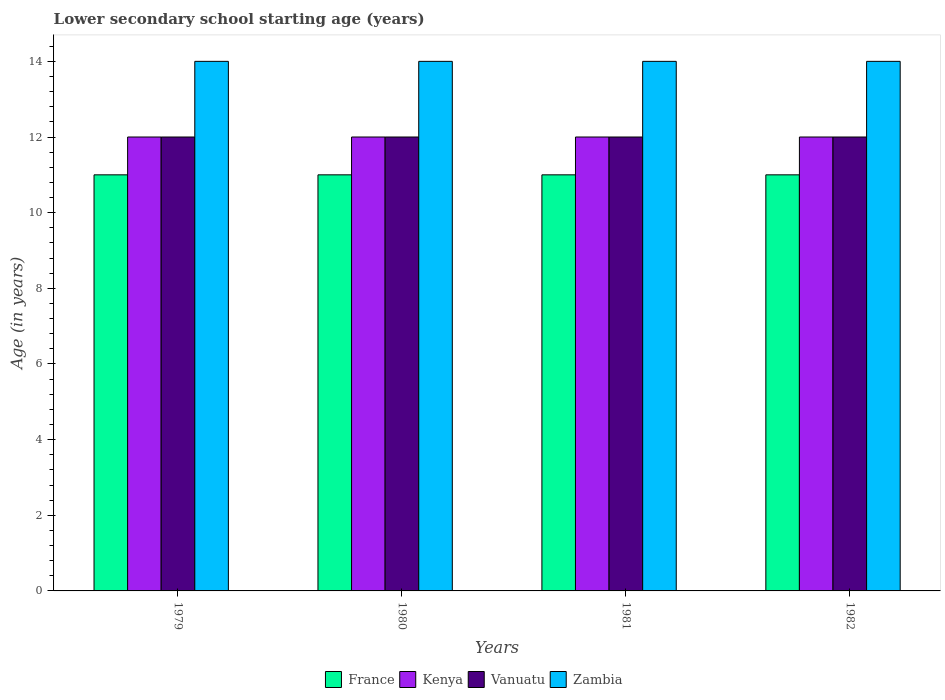How many different coloured bars are there?
Your answer should be compact. 4. How many groups of bars are there?
Provide a short and direct response. 4. Are the number of bars per tick equal to the number of legend labels?
Offer a very short reply. Yes. How many bars are there on the 1st tick from the right?
Provide a succinct answer. 4. What is the label of the 3rd group of bars from the left?
Provide a succinct answer. 1981. What is the lower secondary school starting age of children in Kenya in 1980?
Keep it short and to the point. 12. Across all years, what is the maximum lower secondary school starting age of children in Zambia?
Offer a terse response. 14. Across all years, what is the minimum lower secondary school starting age of children in France?
Make the answer very short. 11. In which year was the lower secondary school starting age of children in Zambia maximum?
Provide a succinct answer. 1979. In which year was the lower secondary school starting age of children in Zambia minimum?
Provide a succinct answer. 1979. What is the total lower secondary school starting age of children in France in the graph?
Ensure brevity in your answer.  44. What is the difference between the lower secondary school starting age of children in Zambia in 1979 and that in 1982?
Keep it short and to the point. 0. What is the difference between the lower secondary school starting age of children in Kenya in 1981 and the lower secondary school starting age of children in France in 1979?
Ensure brevity in your answer.  1. What is the average lower secondary school starting age of children in France per year?
Offer a terse response. 11. In the year 1982, what is the difference between the lower secondary school starting age of children in Vanuatu and lower secondary school starting age of children in Zambia?
Offer a terse response. -2. In how many years, is the lower secondary school starting age of children in Vanuatu greater than 13.6 years?
Offer a very short reply. 0. Is the difference between the lower secondary school starting age of children in Vanuatu in 1979 and 1980 greater than the difference between the lower secondary school starting age of children in Zambia in 1979 and 1980?
Offer a terse response. No. What is the difference between the highest and the second highest lower secondary school starting age of children in Kenya?
Ensure brevity in your answer.  0. Is the sum of the lower secondary school starting age of children in France in 1979 and 1982 greater than the maximum lower secondary school starting age of children in Zambia across all years?
Ensure brevity in your answer.  Yes. What does the 3rd bar from the left in 1980 represents?
Provide a succinct answer. Vanuatu. What does the 2nd bar from the right in 1981 represents?
Give a very brief answer. Vanuatu. How many years are there in the graph?
Offer a terse response. 4. What is the difference between two consecutive major ticks on the Y-axis?
Keep it short and to the point. 2. Does the graph contain any zero values?
Ensure brevity in your answer.  No. Where does the legend appear in the graph?
Offer a very short reply. Bottom center. What is the title of the graph?
Give a very brief answer. Lower secondary school starting age (years). What is the label or title of the X-axis?
Your response must be concise. Years. What is the label or title of the Y-axis?
Keep it short and to the point. Age (in years). What is the Age (in years) in France in 1979?
Provide a succinct answer. 11. What is the Age (in years) of Kenya in 1979?
Your answer should be very brief. 12. What is the Age (in years) in Vanuatu in 1979?
Offer a very short reply. 12. What is the Age (in years) in Zambia in 1979?
Your response must be concise. 14. What is the Age (in years) of France in 1980?
Provide a succinct answer. 11. What is the Age (in years) in Kenya in 1980?
Offer a terse response. 12. What is the Age (in years) of Vanuatu in 1980?
Ensure brevity in your answer.  12. What is the Age (in years) of Zambia in 1980?
Make the answer very short. 14. What is the Age (in years) of Kenya in 1981?
Offer a terse response. 12. What is the Age (in years) in Vanuatu in 1981?
Provide a succinct answer. 12. What is the Age (in years) in Vanuatu in 1982?
Your answer should be compact. 12. What is the Age (in years) in Zambia in 1982?
Your answer should be compact. 14. Across all years, what is the maximum Age (in years) in Kenya?
Offer a terse response. 12. Across all years, what is the maximum Age (in years) of Vanuatu?
Your answer should be very brief. 12. Across all years, what is the maximum Age (in years) of Zambia?
Give a very brief answer. 14. Across all years, what is the minimum Age (in years) in Kenya?
Ensure brevity in your answer.  12. Across all years, what is the minimum Age (in years) of Zambia?
Make the answer very short. 14. What is the total Age (in years) in France in the graph?
Make the answer very short. 44. What is the total Age (in years) of Kenya in the graph?
Offer a terse response. 48. What is the difference between the Age (in years) in Zambia in 1979 and that in 1980?
Offer a very short reply. 0. What is the difference between the Age (in years) of France in 1979 and that in 1981?
Ensure brevity in your answer.  0. What is the difference between the Age (in years) of Zambia in 1979 and that in 1981?
Your response must be concise. 0. What is the difference between the Age (in years) of France in 1979 and that in 1982?
Your answer should be compact. 0. What is the difference between the Age (in years) of France in 1980 and that in 1981?
Give a very brief answer. 0. What is the difference between the Age (in years) of Kenya in 1980 and that in 1982?
Provide a short and direct response. 0. What is the difference between the Age (in years) in Vanuatu in 1980 and that in 1982?
Your response must be concise. 0. What is the difference between the Age (in years) of France in 1981 and that in 1982?
Your answer should be compact. 0. What is the difference between the Age (in years) of Vanuatu in 1981 and that in 1982?
Your answer should be very brief. 0. What is the difference between the Age (in years) in France in 1979 and the Age (in years) in Kenya in 1980?
Keep it short and to the point. -1. What is the difference between the Age (in years) in France in 1979 and the Age (in years) in Zambia in 1980?
Make the answer very short. -3. What is the difference between the Age (in years) in Kenya in 1979 and the Age (in years) in Zambia in 1980?
Your answer should be very brief. -2. What is the difference between the Age (in years) of Vanuatu in 1979 and the Age (in years) of Zambia in 1980?
Provide a short and direct response. -2. What is the difference between the Age (in years) in France in 1979 and the Age (in years) in Kenya in 1981?
Your answer should be very brief. -1. What is the difference between the Age (in years) in Vanuatu in 1979 and the Age (in years) in Zambia in 1981?
Give a very brief answer. -2. What is the difference between the Age (in years) of Kenya in 1979 and the Age (in years) of Vanuatu in 1982?
Offer a terse response. 0. What is the difference between the Age (in years) in Kenya in 1979 and the Age (in years) in Zambia in 1982?
Your response must be concise. -2. What is the difference between the Age (in years) of Vanuatu in 1979 and the Age (in years) of Zambia in 1982?
Offer a very short reply. -2. What is the difference between the Age (in years) of France in 1980 and the Age (in years) of Kenya in 1981?
Offer a terse response. -1. What is the difference between the Age (in years) of France in 1980 and the Age (in years) of Vanuatu in 1981?
Offer a very short reply. -1. What is the difference between the Age (in years) in Kenya in 1980 and the Age (in years) in Zambia in 1981?
Your response must be concise. -2. What is the difference between the Age (in years) in Vanuatu in 1980 and the Age (in years) in Zambia in 1981?
Offer a terse response. -2. What is the difference between the Age (in years) in Vanuatu in 1980 and the Age (in years) in Zambia in 1982?
Your answer should be compact. -2. What is the difference between the Age (in years) in France in 1981 and the Age (in years) in Zambia in 1982?
Your response must be concise. -3. What is the difference between the Age (in years) of Kenya in 1981 and the Age (in years) of Vanuatu in 1982?
Your response must be concise. 0. What is the difference between the Age (in years) in Kenya in 1981 and the Age (in years) in Zambia in 1982?
Keep it short and to the point. -2. What is the average Age (in years) in France per year?
Provide a short and direct response. 11. What is the average Age (in years) of Kenya per year?
Ensure brevity in your answer.  12. What is the average Age (in years) of Vanuatu per year?
Your response must be concise. 12. What is the average Age (in years) of Zambia per year?
Give a very brief answer. 14. In the year 1979, what is the difference between the Age (in years) in France and Age (in years) in Kenya?
Give a very brief answer. -1. In the year 1979, what is the difference between the Age (in years) in France and Age (in years) in Vanuatu?
Offer a very short reply. -1. In the year 1979, what is the difference between the Age (in years) in France and Age (in years) in Zambia?
Offer a very short reply. -3. In the year 1979, what is the difference between the Age (in years) of Kenya and Age (in years) of Vanuatu?
Provide a succinct answer. 0. In the year 1979, what is the difference between the Age (in years) in Kenya and Age (in years) in Zambia?
Keep it short and to the point. -2. In the year 1980, what is the difference between the Age (in years) in France and Age (in years) in Vanuatu?
Offer a terse response. -1. In the year 1980, what is the difference between the Age (in years) of Kenya and Age (in years) of Zambia?
Offer a terse response. -2. In the year 1981, what is the difference between the Age (in years) in France and Age (in years) in Kenya?
Your response must be concise. -1. In the year 1981, what is the difference between the Age (in years) of France and Age (in years) of Vanuatu?
Give a very brief answer. -1. In the year 1981, what is the difference between the Age (in years) of France and Age (in years) of Zambia?
Provide a short and direct response. -3. In the year 1981, what is the difference between the Age (in years) of Kenya and Age (in years) of Vanuatu?
Ensure brevity in your answer.  0. In the year 1981, what is the difference between the Age (in years) in Kenya and Age (in years) in Zambia?
Make the answer very short. -2. In the year 1982, what is the difference between the Age (in years) of France and Age (in years) of Kenya?
Your answer should be very brief. -1. In the year 1982, what is the difference between the Age (in years) in France and Age (in years) in Zambia?
Your answer should be compact. -3. In the year 1982, what is the difference between the Age (in years) of Kenya and Age (in years) of Vanuatu?
Your response must be concise. 0. In the year 1982, what is the difference between the Age (in years) in Kenya and Age (in years) in Zambia?
Give a very brief answer. -2. In the year 1982, what is the difference between the Age (in years) in Vanuatu and Age (in years) in Zambia?
Make the answer very short. -2. What is the ratio of the Age (in years) in France in 1979 to that in 1980?
Your response must be concise. 1. What is the ratio of the Age (in years) of Kenya in 1979 to that in 1980?
Give a very brief answer. 1. What is the ratio of the Age (in years) in Zambia in 1979 to that in 1980?
Your response must be concise. 1. What is the ratio of the Age (in years) in France in 1979 to that in 1981?
Keep it short and to the point. 1. What is the ratio of the Age (in years) in Vanuatu in 1979 to that in 1981?
Your response must be concise. 1. What is the ratio of the Age (in years) in Zambia in 1979 to that in 1981?
Offer a terse response. 1. What is the ratio of the Age (in years) of Vanuatu in 1979 to that in 1982?
Offer a very short reply. 1. What is the ratio of the Age (in years) of Vanuatu in 1980 to that in 1981?
Provide a short and direct response. 1. What is the ratio of the Age (in years) in Zambia in 1980 to that in 1982?
Offer a very short reply. 1. What is the ratio of the Age (in years) of Vanuatu in 1981 to that in 1982?
Your answer should be compact. 1. What is the difference between the highest and the second highest Age (in years) in Vanuatu?
Ensure brevity in your answer.  0. What is the difference between the highest and the second highest Age (in years) in Zambia?
Ensure brevity in your answer.  0. What is the difference between the highest and the lowest Age (in years) of France?
Give a very brief answer. 0. What is the difference between the highest and the lowest Age (in years) in Vanuatu?
Give a very brief answer. 0. 